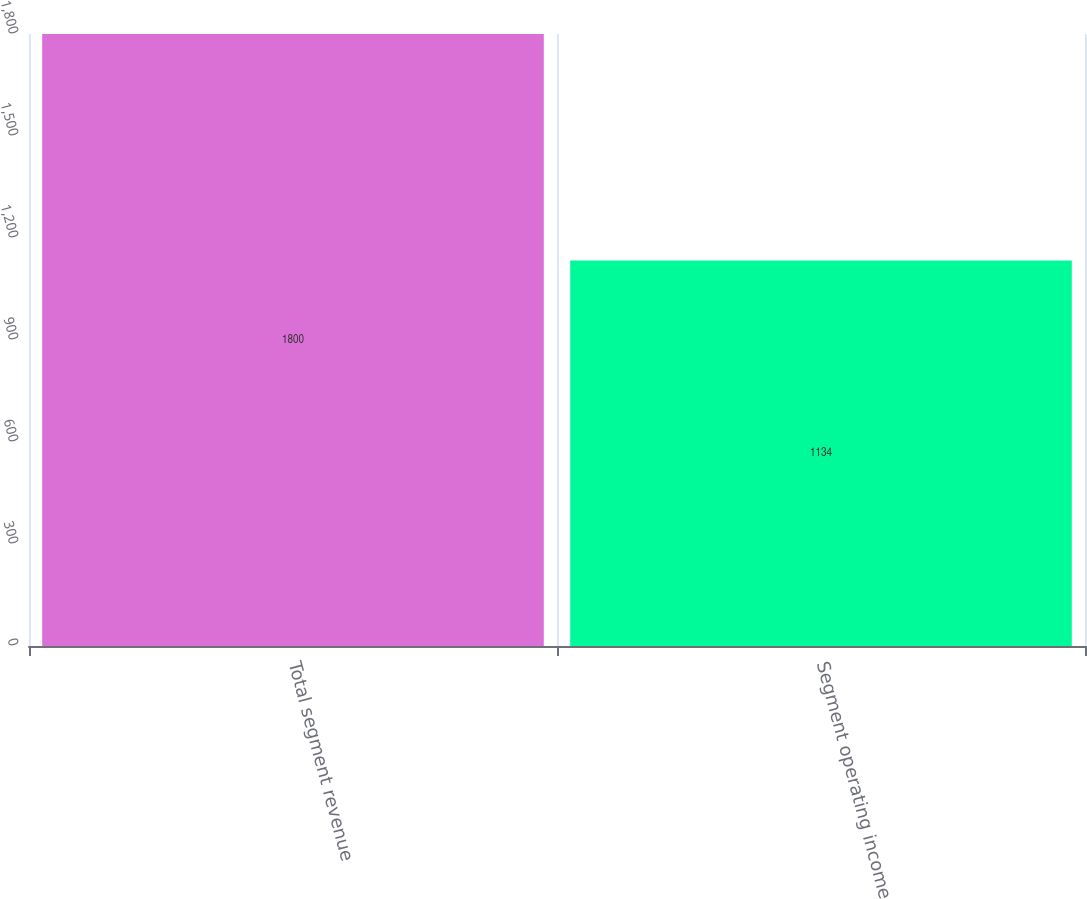Convert chart to OTSL. <chart><loc_0><loc_0><loc_500><loc_500><bar_chart><fcel>Total segment revenue<fcel>Segment operating income<nl><fcel>1800<fcel>1134<nl></chart> 